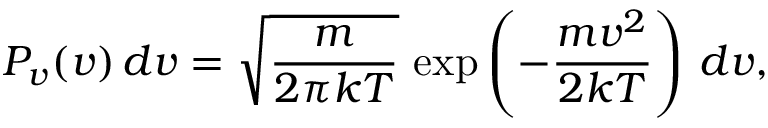Convert formula to latex. <formula><loc_0><loc_0><loc_500><loc_500>P _ { v } ( v ) \, d v = { \sqrt { \frac { m } { 2 \pi k T } } } \, \exp \left ( - { \frac { m v ^ { 2 } } { 2 k T } } \right ) \, d v ,</formula> 